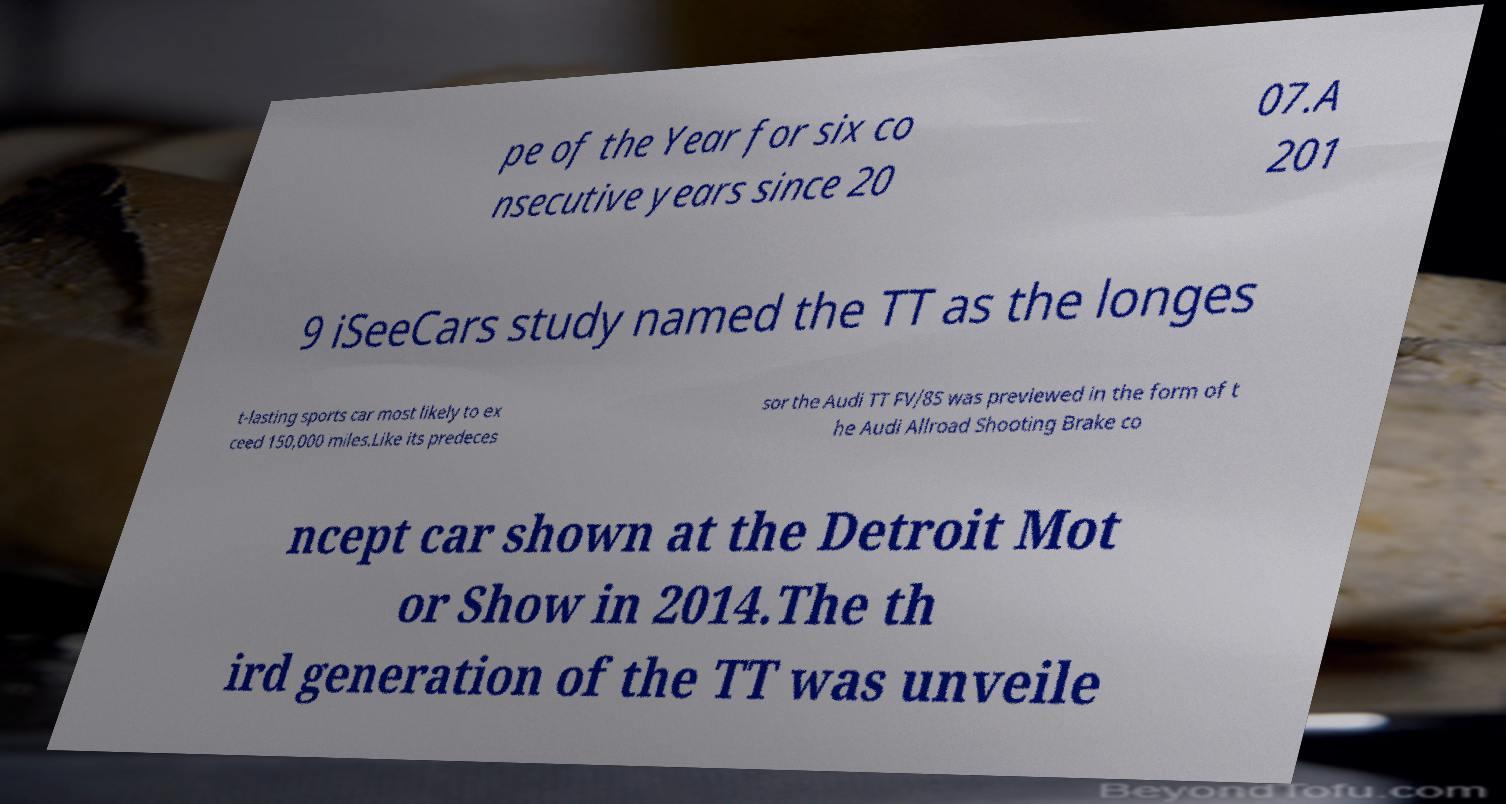Could you extract and type out the text from this image? pe of the Year for six co nsecutive years since 20 07.A 201 9 iSeeCars study named the TT as the longes t-lasting sports car most likely to ex ceed 150,000 miles.Like its predeces sor the Audi TT FV/8S was previewed in the form of t he Audi Allroad Shooting Brake co ncept car shown at the Detroit Mot or Show in 2014.The th ird generation of the TT was unveile 